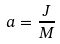<formula> <loc_0><loc_0><loc_500><loc_500>a = \frac { J } { M }</formula> 